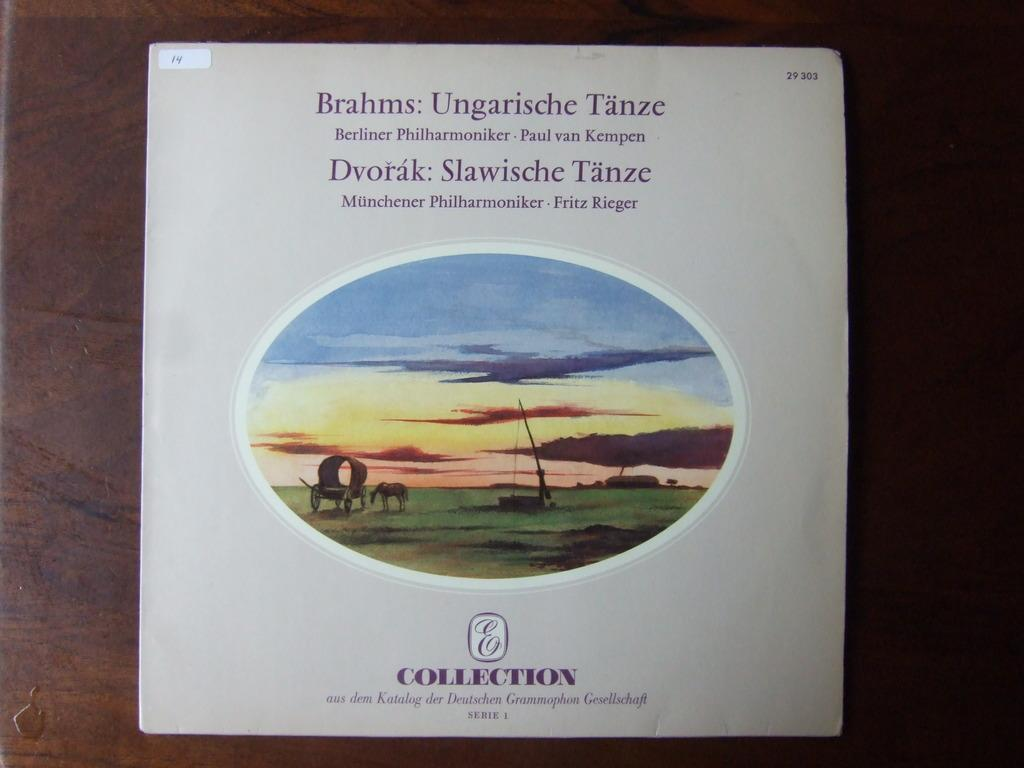<image>
Share a concise interpretation of the image provided. A book with the title Brahms: Ungarische Tanze. 